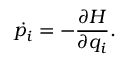Convert formula to latex. <formula><loc_0><loc_0><loc_500><loc_500>\dot { p _ { i } } = - \frac { \partial H } { \partial q _ { i } } .</formula> 